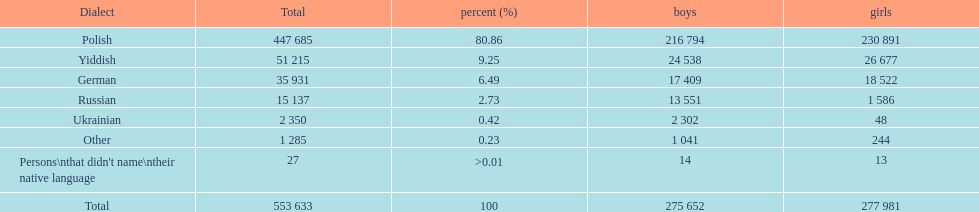How many speakers (of any language) are represented on the table ? 553 633. 